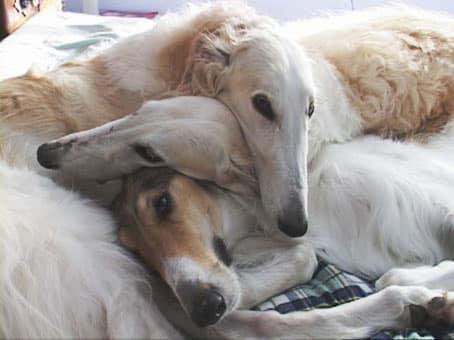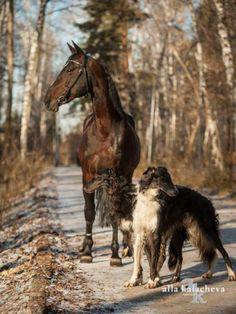The first image is the image on the left, the second image is the image on the right. Analyze the images presented: Is the assertion "There is a horse and two dogs staring in the same direction" valid? Answer yes or no. Yes. The first image is the image on the left, the second image is the image on the right. Given the left and right images, does the statement "The combined images include a person near a dog and a dog next to a horse." hold true? Answer yes or no. No. 